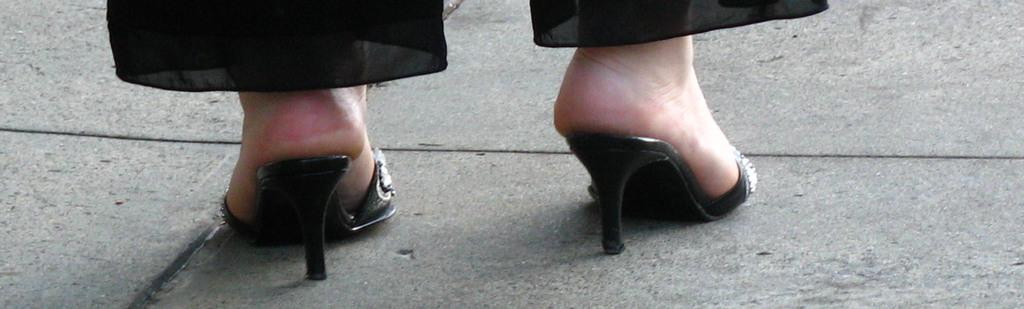What part of a person can be seen in the image? There are legs of a person visible in the image. What color are the pants worn by the person in the image? The person is wearing black pants. What type of footwear is the person wearing in the image? The person is wearing black heels. What type of silverware is the maid using in the image? There is no maid or silverware present in the image. How many crows can be seen in the image? There are no crows present in the image. 